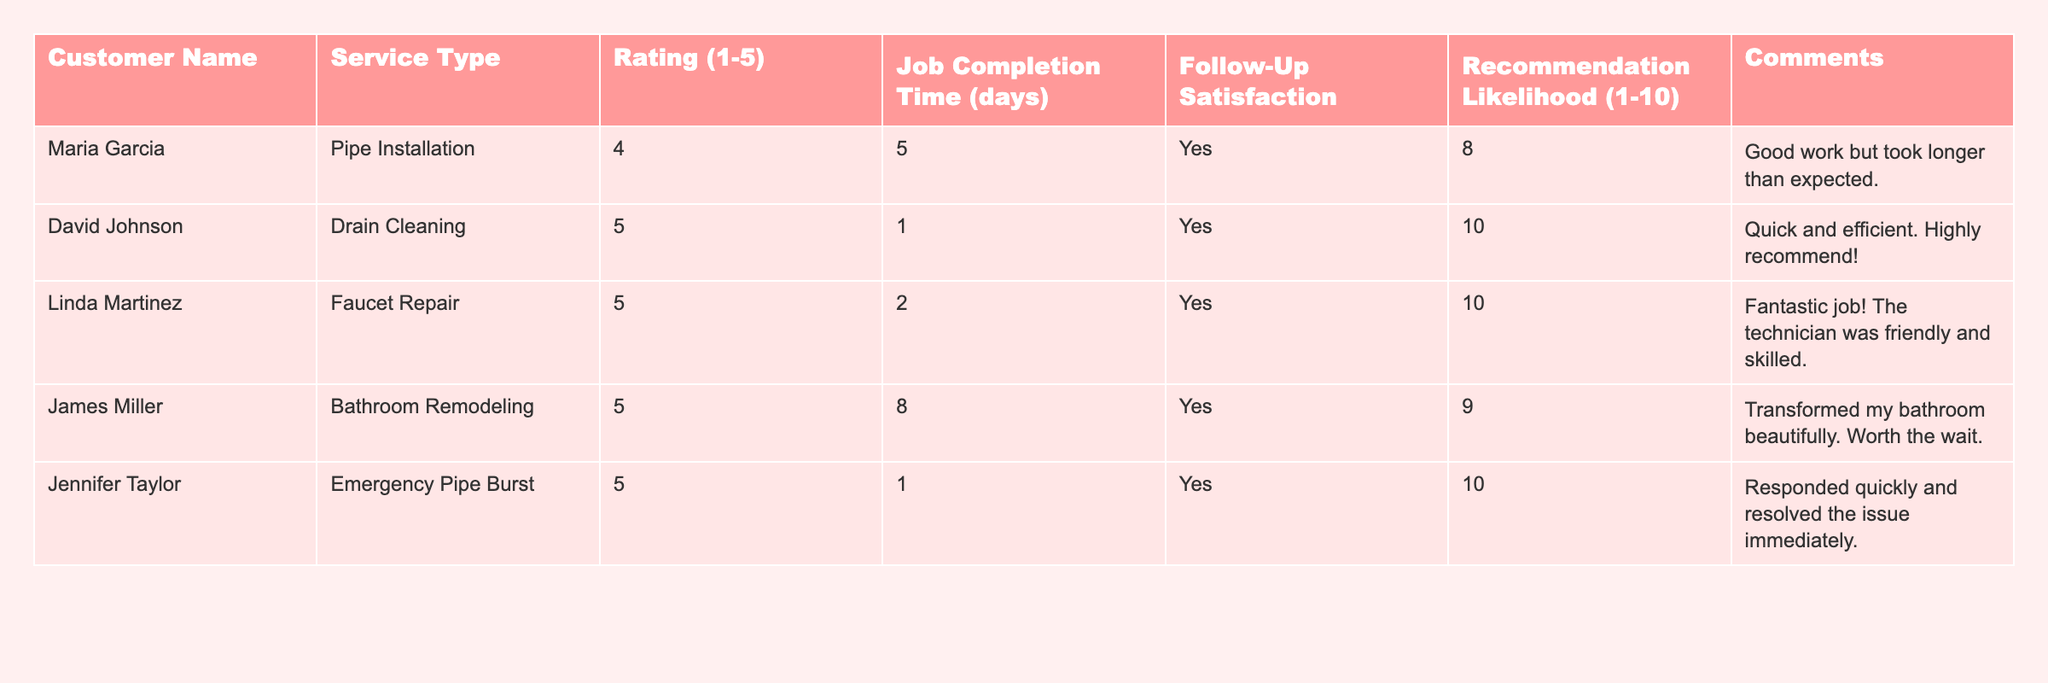What is the highest customer rating in the table? The highest rating given in the table is **5**, which appears for multiple services.
Answer: 5 Who provided a rating of 4? The only customer who rated their service a **4** is **Maria Garcia**.
Answer: Maria Garcia How many customers would recommend our service with a likelihood of 10? The customers that rated a **10** for recommendation likelihood are **David Johnson**, **Linda Martinez**, and **Jennifer Taylor**, totaling **3**.
Answer: 3 What is the average job completion time for the jobs listed? The job completion times are **5, 1, 2, 8, and 1** days. Summing these gives **17 days**, and dividing by the number of jobs (5) gives **3.4 days**.
Answer: 3.4 days Did James Miller indicate he would recommend our services? Yes, James Miller responded **Yes** for follow-up satisfaction, indicating he would recommend the services.
Answer: Yes How does the rating of the bathroom remodeling compare to the faucet repair in terms of recommendation likelihood? The bathroom remodeling received a rating of **5** and a recommendation likelihood of **9**, while the faucet repair also received a **5** but with a likelihood of **10**. Thus, faucet repair had a higher recommendation likelihood.
Answer: Faucet repair is higher Is there any comment about a delay with a job? Yes, **Maria Garcia's** comment states work took longer than expected.
Answer: Yes What is the total number of jobs that received a rating of 5? The jobs that received a rating of **5** are **David Johnson**, **Linda Martinez**, **James Miller**, and **Jennifer Taylor**, totaling **4** jobs.
Answer: 4 Which customer had the longest job completion time? The longest job completion time listed is **8 days**, and this was for **James Miller**'s bathroom remodeling service.
Answer: James Miller What percentage of customers stated they would recommend our services? All customers stated they would recommend our services as each follow-up satisfaction entry is **Yes**. With **5** customers, the percentage is **100%**.
Answer: 100% If the average rating is taken from all ratings, what is it? The ratings are **4, 5, 5, 5, and 5**. Adding these gives **24**, and dividing by 5 customers gives an average rating of **4.8**.
Answer: 4.8 